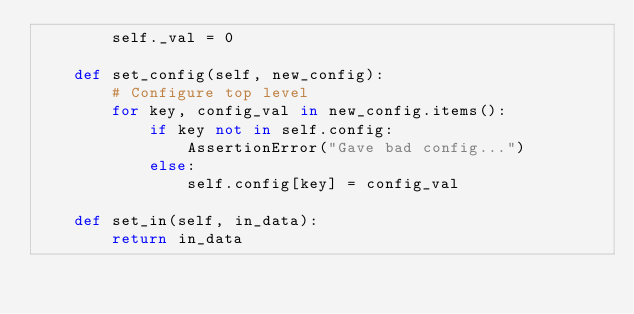Convert code to text. <code><loc_0><loc_0><loc_500><loc_500><_Python_>        self._val = 0

    def set_config(self, new_config):
        # Configure top level
        for key, config_val in new_config.items():
            if key not in self.config:
                AssertionError("Gave bad config...")
            else:
                self.config[key] = config_val

    def set_in(self, in_data):
        return in_data
</code> 